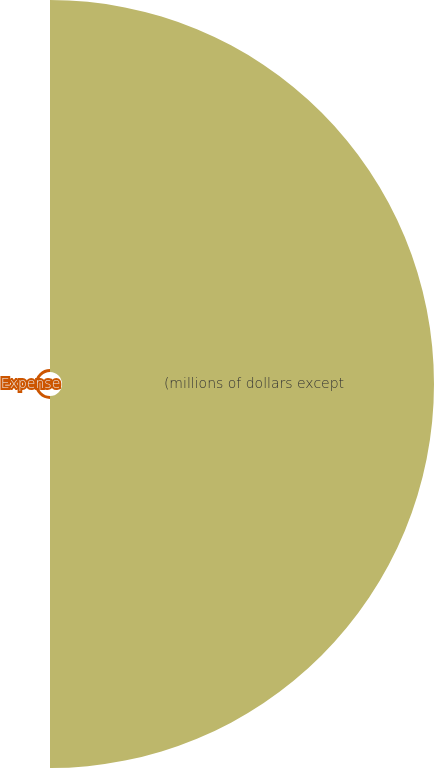Convert chart to OTSL. <chart><loc_0><loc_0><loc_500><loc_500><pie_chart><fcel>(millions of dollars except<fcel>Expense<nl><fcel>99.22%<fcel>0.78%<nl></chart> 